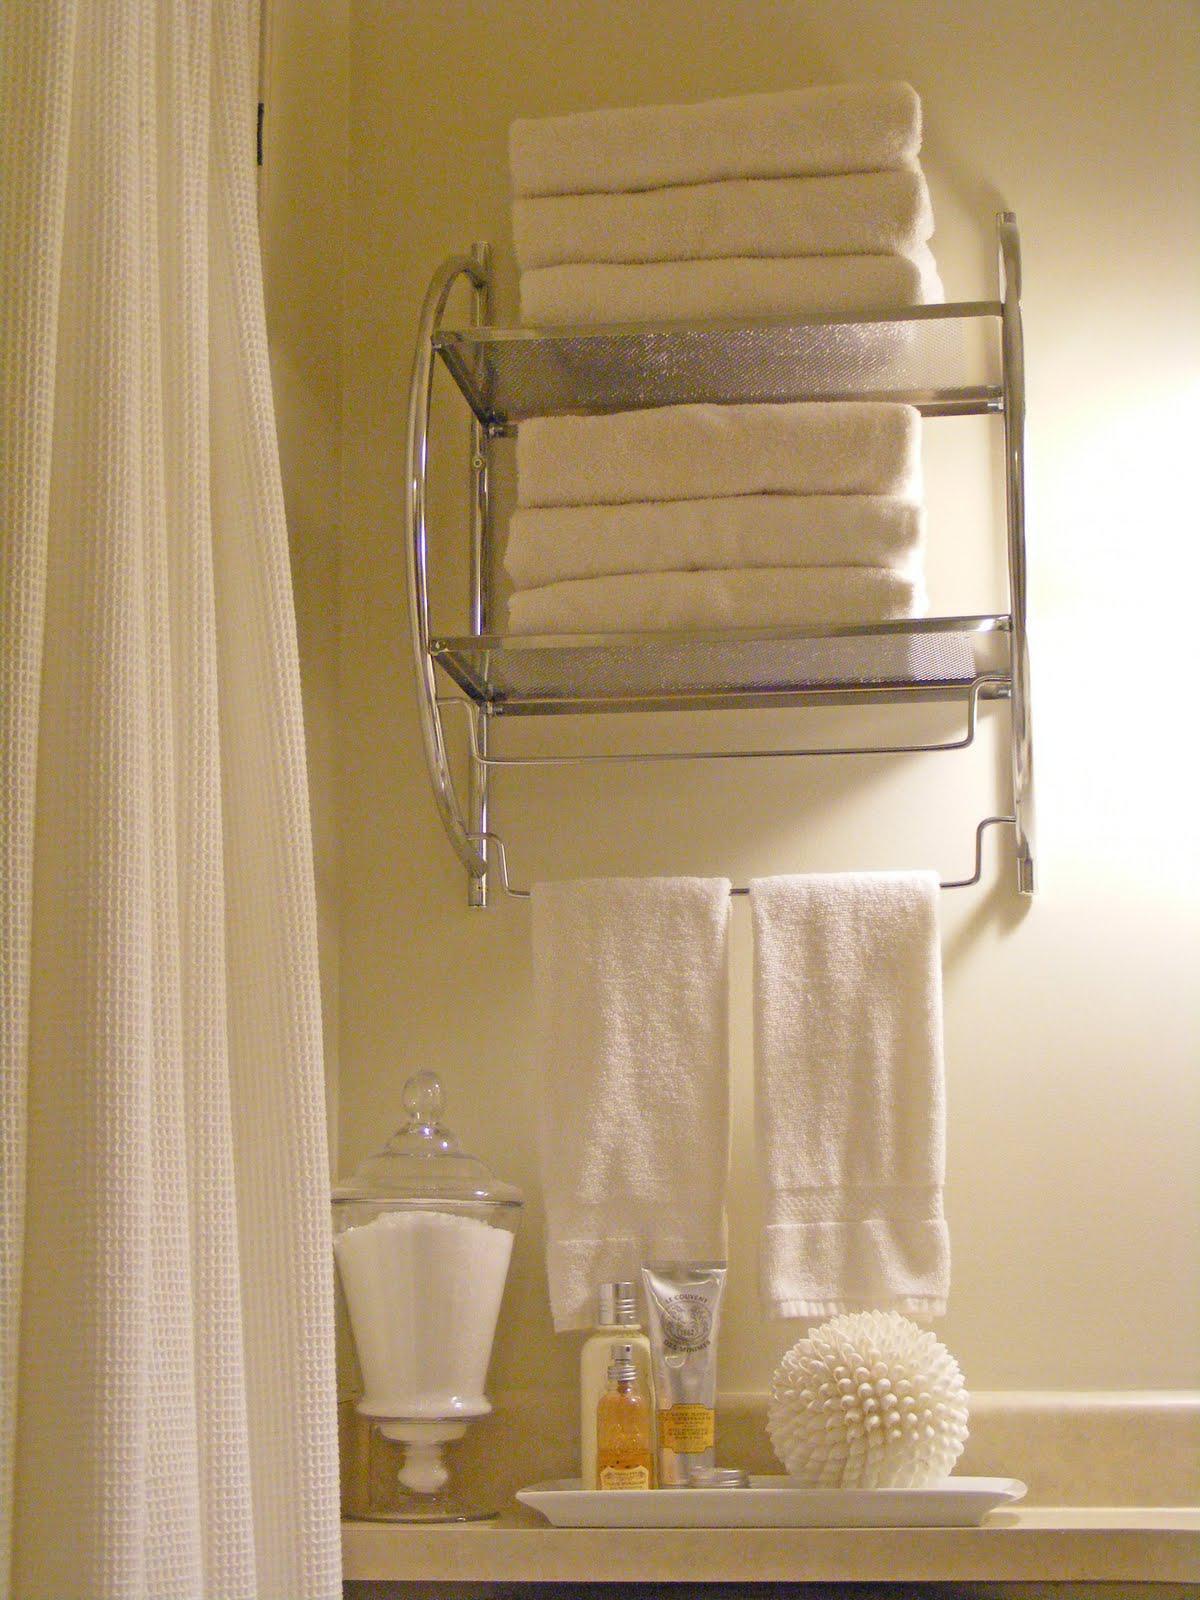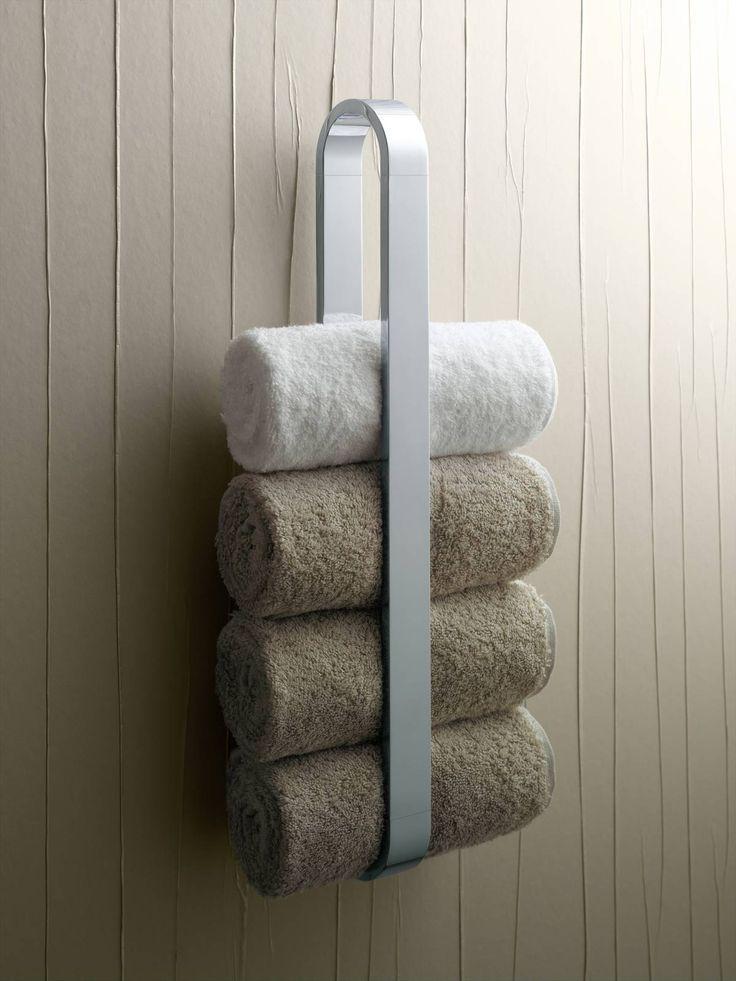The first image is the image on the left, the second image is the image on the right. Evaluate the accuracy of this statement regarding the images: "There is a toilet in the image on the left". Is it true? Answer yes or no. No. 